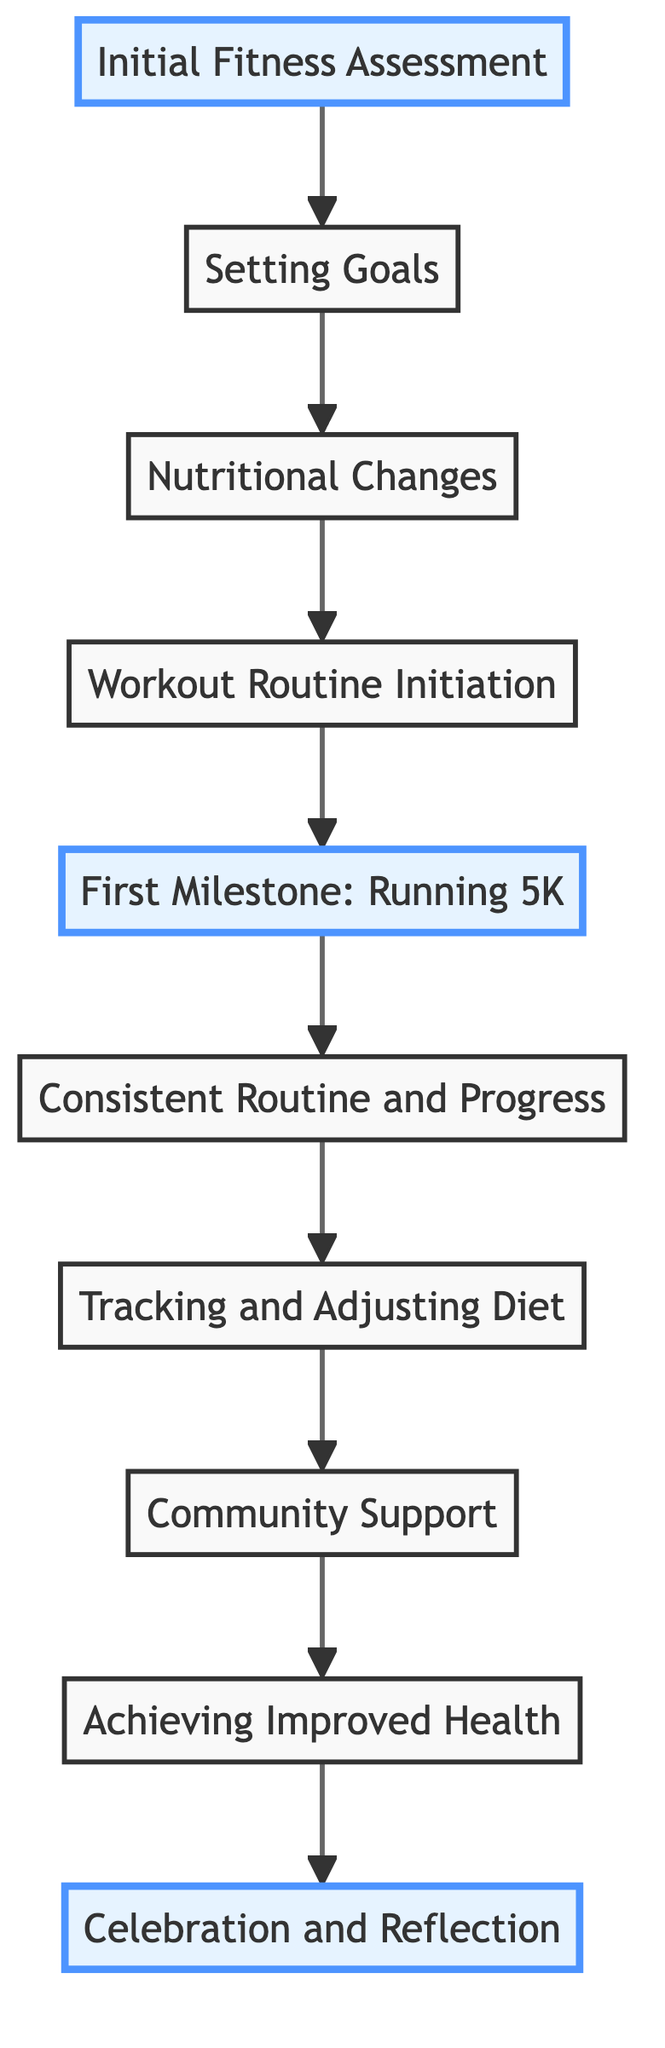What is the first step in the fitness transformation journey? The first step is "Initial Fitness Assessment," which involves getting a health check-up and assessing the initial fitness level. This is indicated as the starting node in the diagram.
Answer: Initial Fitness Assessment How many milestones are highlighted in the diagram? There are three highlighted milestones: "Initial Fitness Assessment," "First Milestone: Running 5K," and "Celebration and Reflection." These nodes have been marked with a different style in the diagram.
Answer: Three What is the relationship between "Setting Goals" and "Nutritional Changes"? "Setting Goals" leads to "Nutritional Changes," meaning that after establishing fitness goals, the next step is to make dietary changes. This relationship is shown by the directed arrow.
Answer: Leads to What is the last step in the fitness transformation journey? The last step is "Celebration and Reflection," which involves reflecting on the journey, celebrating achievements, and planning for future goals. This is the final node in the diagram.
Answer: Celebration and Reflection What step comes immediately before "Tracking and Adjusting Diet"? The step that comes immediately before "Tracking and Adjusting Diet" is "Consistent Routine and Progress," which indicates that individuals should first maintain a consistent workout routine before tracking their diet.
Answer: Consistent Routine and Progress How does "Community Support" contribute to achieving improved health? "Community Support" facilitates motivation and sharing experiences among individuals, which can enhance their fitness journey and lead to "Achieving Improved Health." This is demonstrated by the directional flow from "Community Support" to "Achieving Improved Health."
Answer: Facilitates motivation 